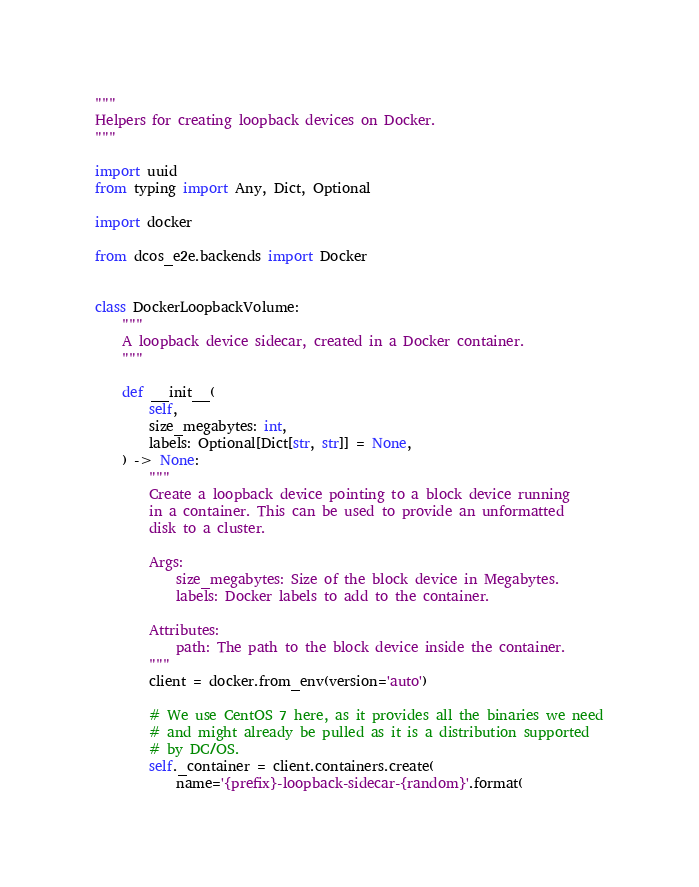<code> <loc_0><loc_0><loc_500><loc_500><_Python_>"""
Helpers for creating loopback devices on Docker.
"""

import uuid
from typing import Any, Dict, Optional

import docker

from dcos_e2e.backends import Docker


class DockerLoopbackVolume:
    """
    A loopback device sidecar, created in a Docker container.
    """

    def __init__(
        self,
        size_megabytes: int,
        labels: Optional[Dict[str, str]] = None,
    ) -> None:
        """
        Create a loopback device pointing to a block device running
        in a container. This can be used to provide an unformatted
        disk to a cluster.

        Args:
            size_megabytes: Size of the block device in Megabytes.
            labels: Docker labels to add to the container.

        Attributes:
            path: The path to the block device inside the container.
        """
        client = docker.from_env(version='auto')

        # We use CentOS 7 here, as it provides all the binaries we need
        # and might already be pulled as it is a distribution supported
        # by DC/OS.
        self._container = client.containers.create(
            name='{prefix}-loopback-sidecar-{random}'.format(</code> 